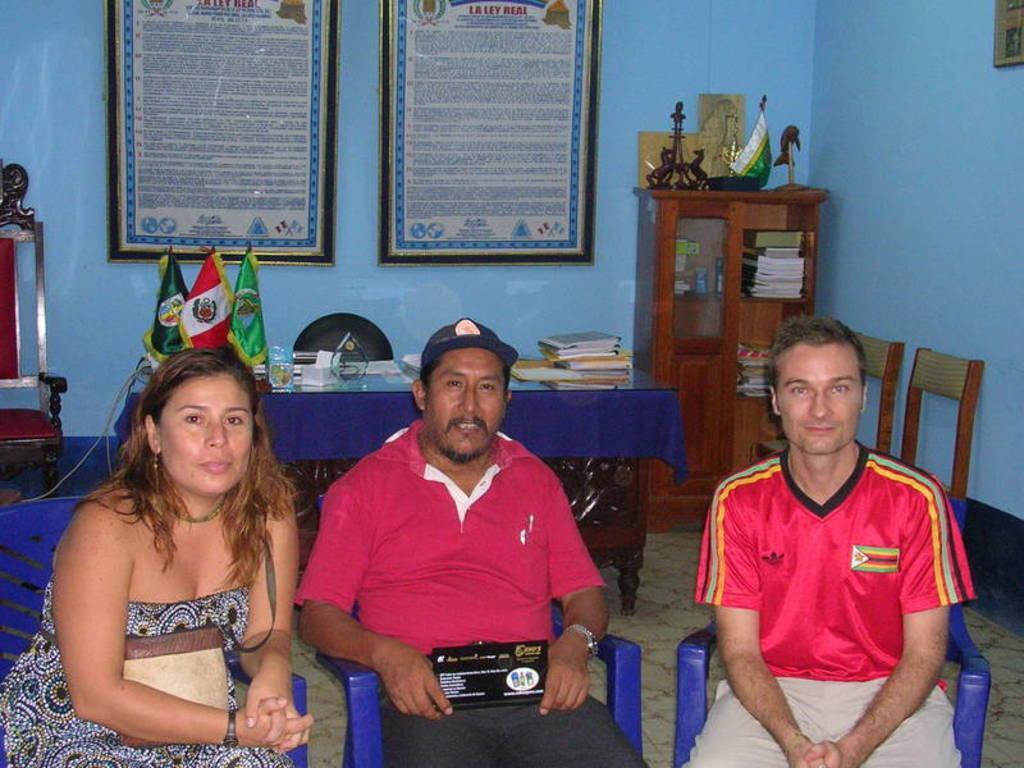In one or two sentences, can you explain what this image depicts? In this picture I can see few people sitting in the chairs and a man holding something in his hands and I can see couple of frames with some text on the wall and I can see chairs, few books and flags on the table. I can see a cupboard and few books in the cupboard and few items on the cupboard. 